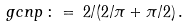<formula> <loc_0><loc_0><loc_500><loc_500>\ g c n p \, \colon = \, 2 / ( 2 / \pi + \pi / 2 ) \, .</formula> 